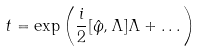Convert formula to latex. <formula><loc_0><loc_0><loc_500><loc_500>t = \exp \left ( \frac { i } { 2 } [ \hat { \varphi } , \Lambda ] \Lambda + \dots \right )</formula> 